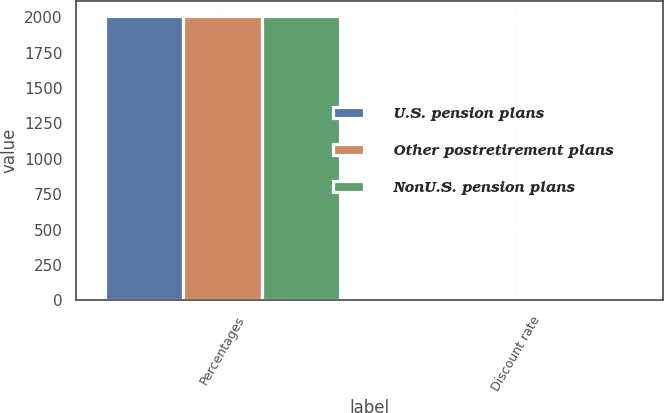Convert chart. <chart><loc_0><loc_0><loc_500><loc_500><stacked_bar_chart><ecel><fcel>Percentages<fcel>Discount rate<nl><fcel>U.S. pension plans<fcel>2013<fcel>3.67<nl><fcel>Other postretirement plans<fcel>2013<fcel>3.85<nl><fcel>NonU.S. pension plans<fcel>2013<fcel>3.4<nl></chart> 